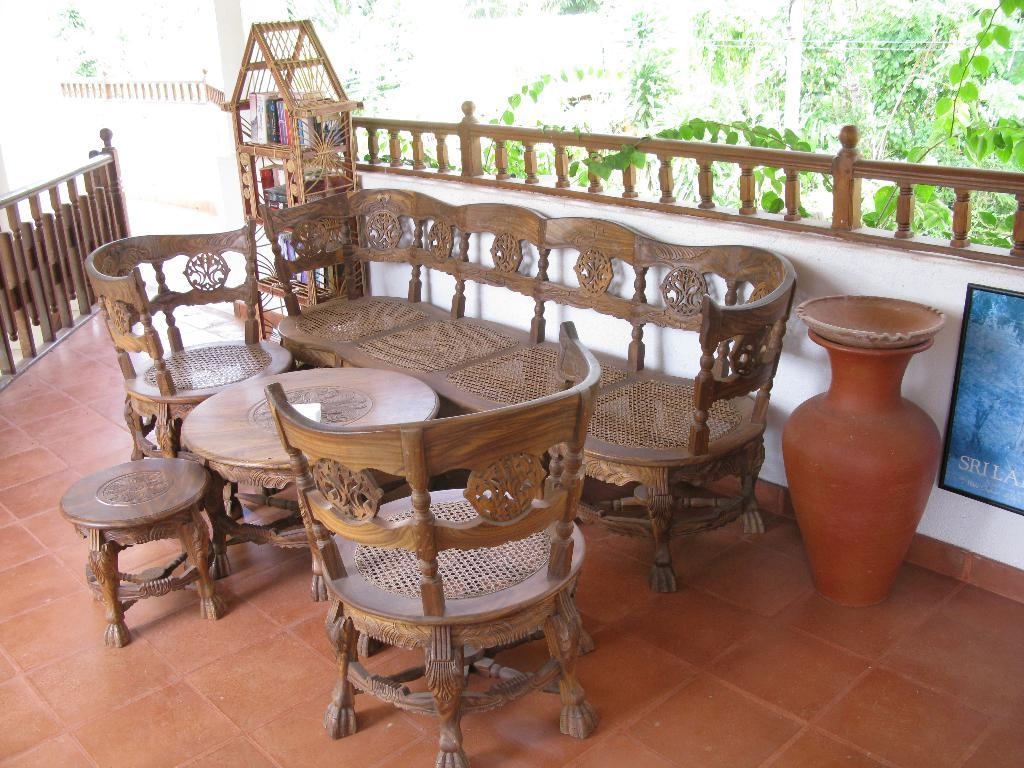What type of furniture is present in the image? There is a wooden sofa, chairs, and a table in the image. What is located near the wooden sofa? There is a flower pot in the image. What can be found inside the wooden cupboard in the image? The wooden cupboard contains books. What is visible in the background of the image? Trees are visible in the background of the image. What type of meat is being served on the table in the image? There is no meat present in the image; it features a wooden sofa, chairs, a table, a flower pot, a wooden cupboard with books, and trees in the background. Can you tell me how many grapes are in the flower pot in the image? There are no grapes present in the image; it features a wooden sofa, chairs, a table, a flower pot, a wooden cupboard with books, and trees in the background. 